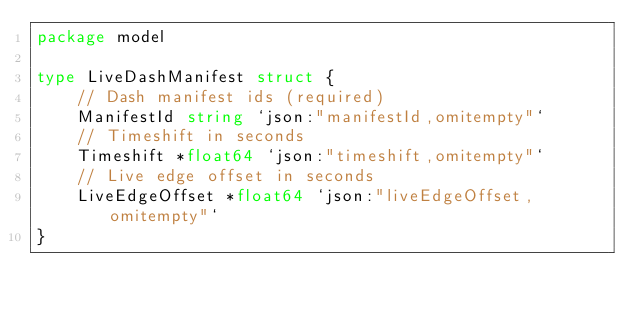Convert code to text. <code><loc_0><loc_0><loc_500><loc_500><_Go_>package model

type LiveDashManifest struct {
	// Dash manifest ids (required)
	ManifestId string `json:"manifestId,omitempty"`
	// Timeshift in seconds
	Timeshift *float64 `json:"timeshift,omitempty"`
	// Live edge offset in seconds
	LiveEdgeOffset *float64 `json:"liveEdgeOffset,omitempty"`
}

</code> 